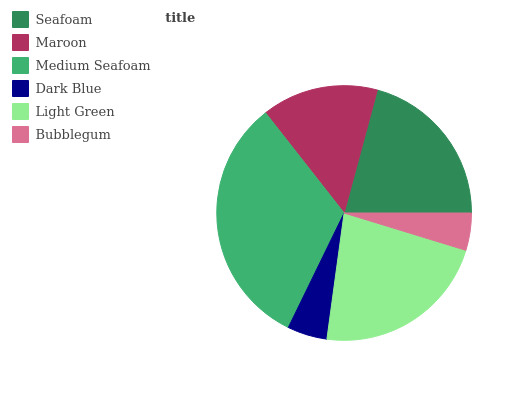Is Bubblegum the minimum?
Answer yes or no. Yes. Is Medium Seafoam the maximum?
Answer yes or no. Yes. Is Maroon the minimum?
Answer yes or no. No. Is Maroon the maximum?
Answer yes or no. No. Is Seafoam greater than Maroon?
Answer yes or no. Yes. Is Maroon less than Seafoam?
Answer yes or no. Yes. Is Maroon greater than Seafoam?
Answer yes or no. No. Is Seafoam less than Maroon?
Answer yes or no. No. Is Seafoam the high median?
Answer yes or no. Yes. Is Maroon the low median?
Answer yes or no. Yes. Is Maroon the high median?
Answer yes or no. No. Is Light Green the low median?
Answer yes or no. No. 